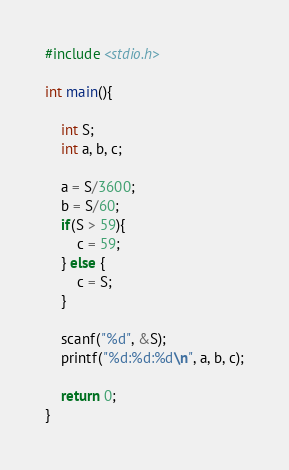<code> <loc_0><loc_0><loc_500><loc_500><_C_>#include <stdio.h>

int main(){

    int S;
    int a, b, c;

    a = S/3600;
    b = S/60;
    if(S > 59){
        c = 59;
    } else {
        c = S;
    }

    scanf("%d", &S);
    printf("%d:%d:%d\n", a, b, c);

    return 0;
}</code> 